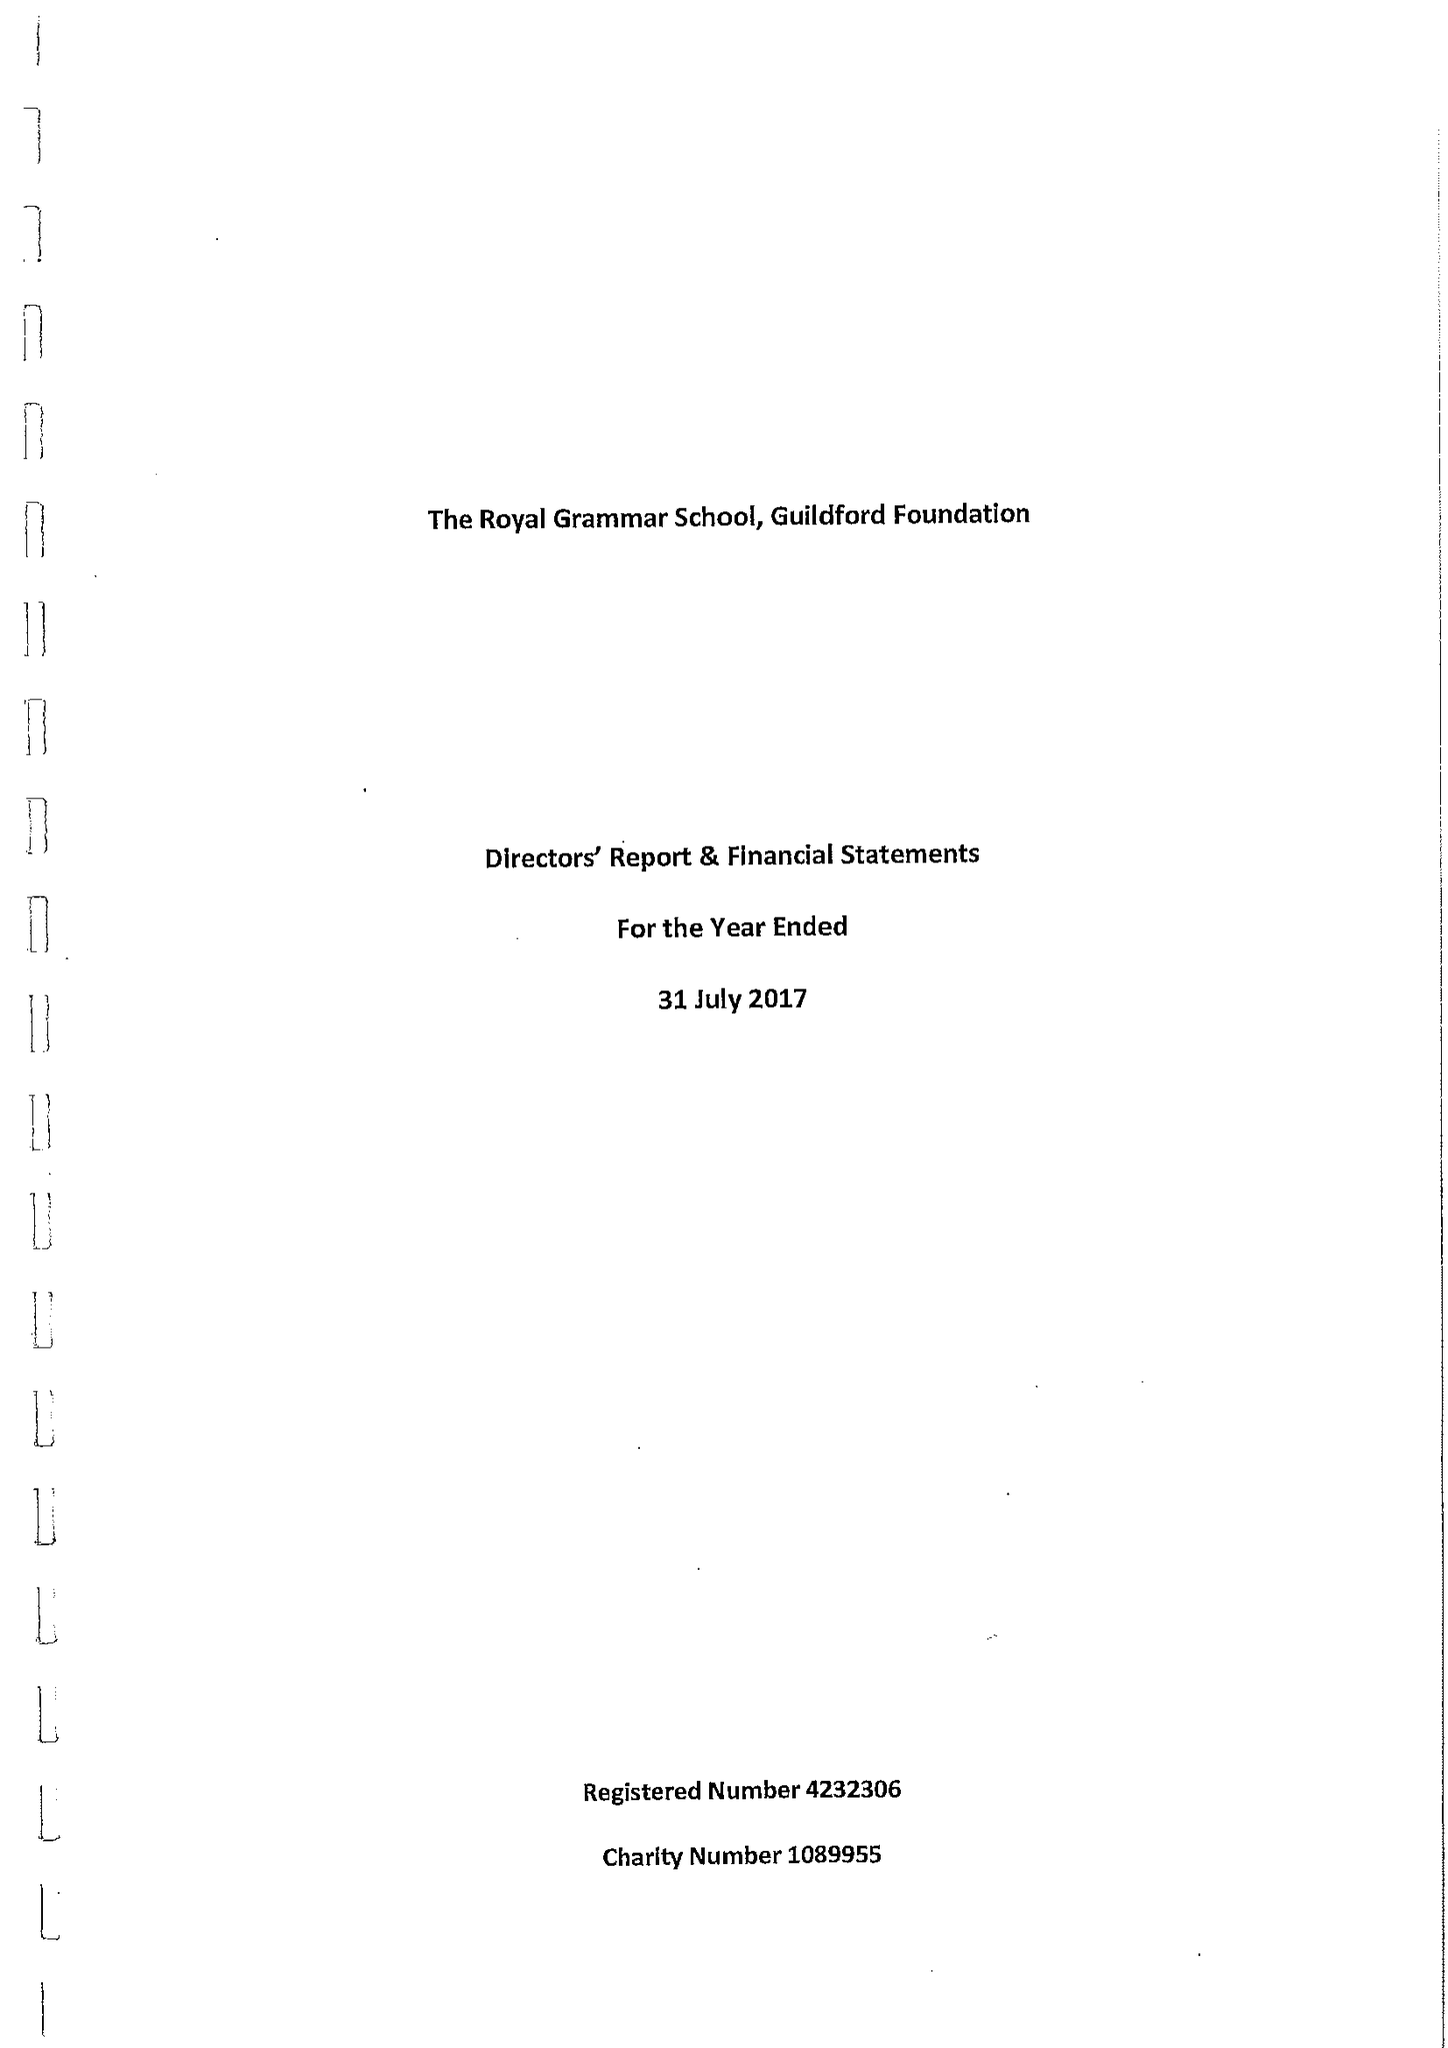What is the value for the address__street_line?
Answer the question using a single word or phrase. HIGH STREET 